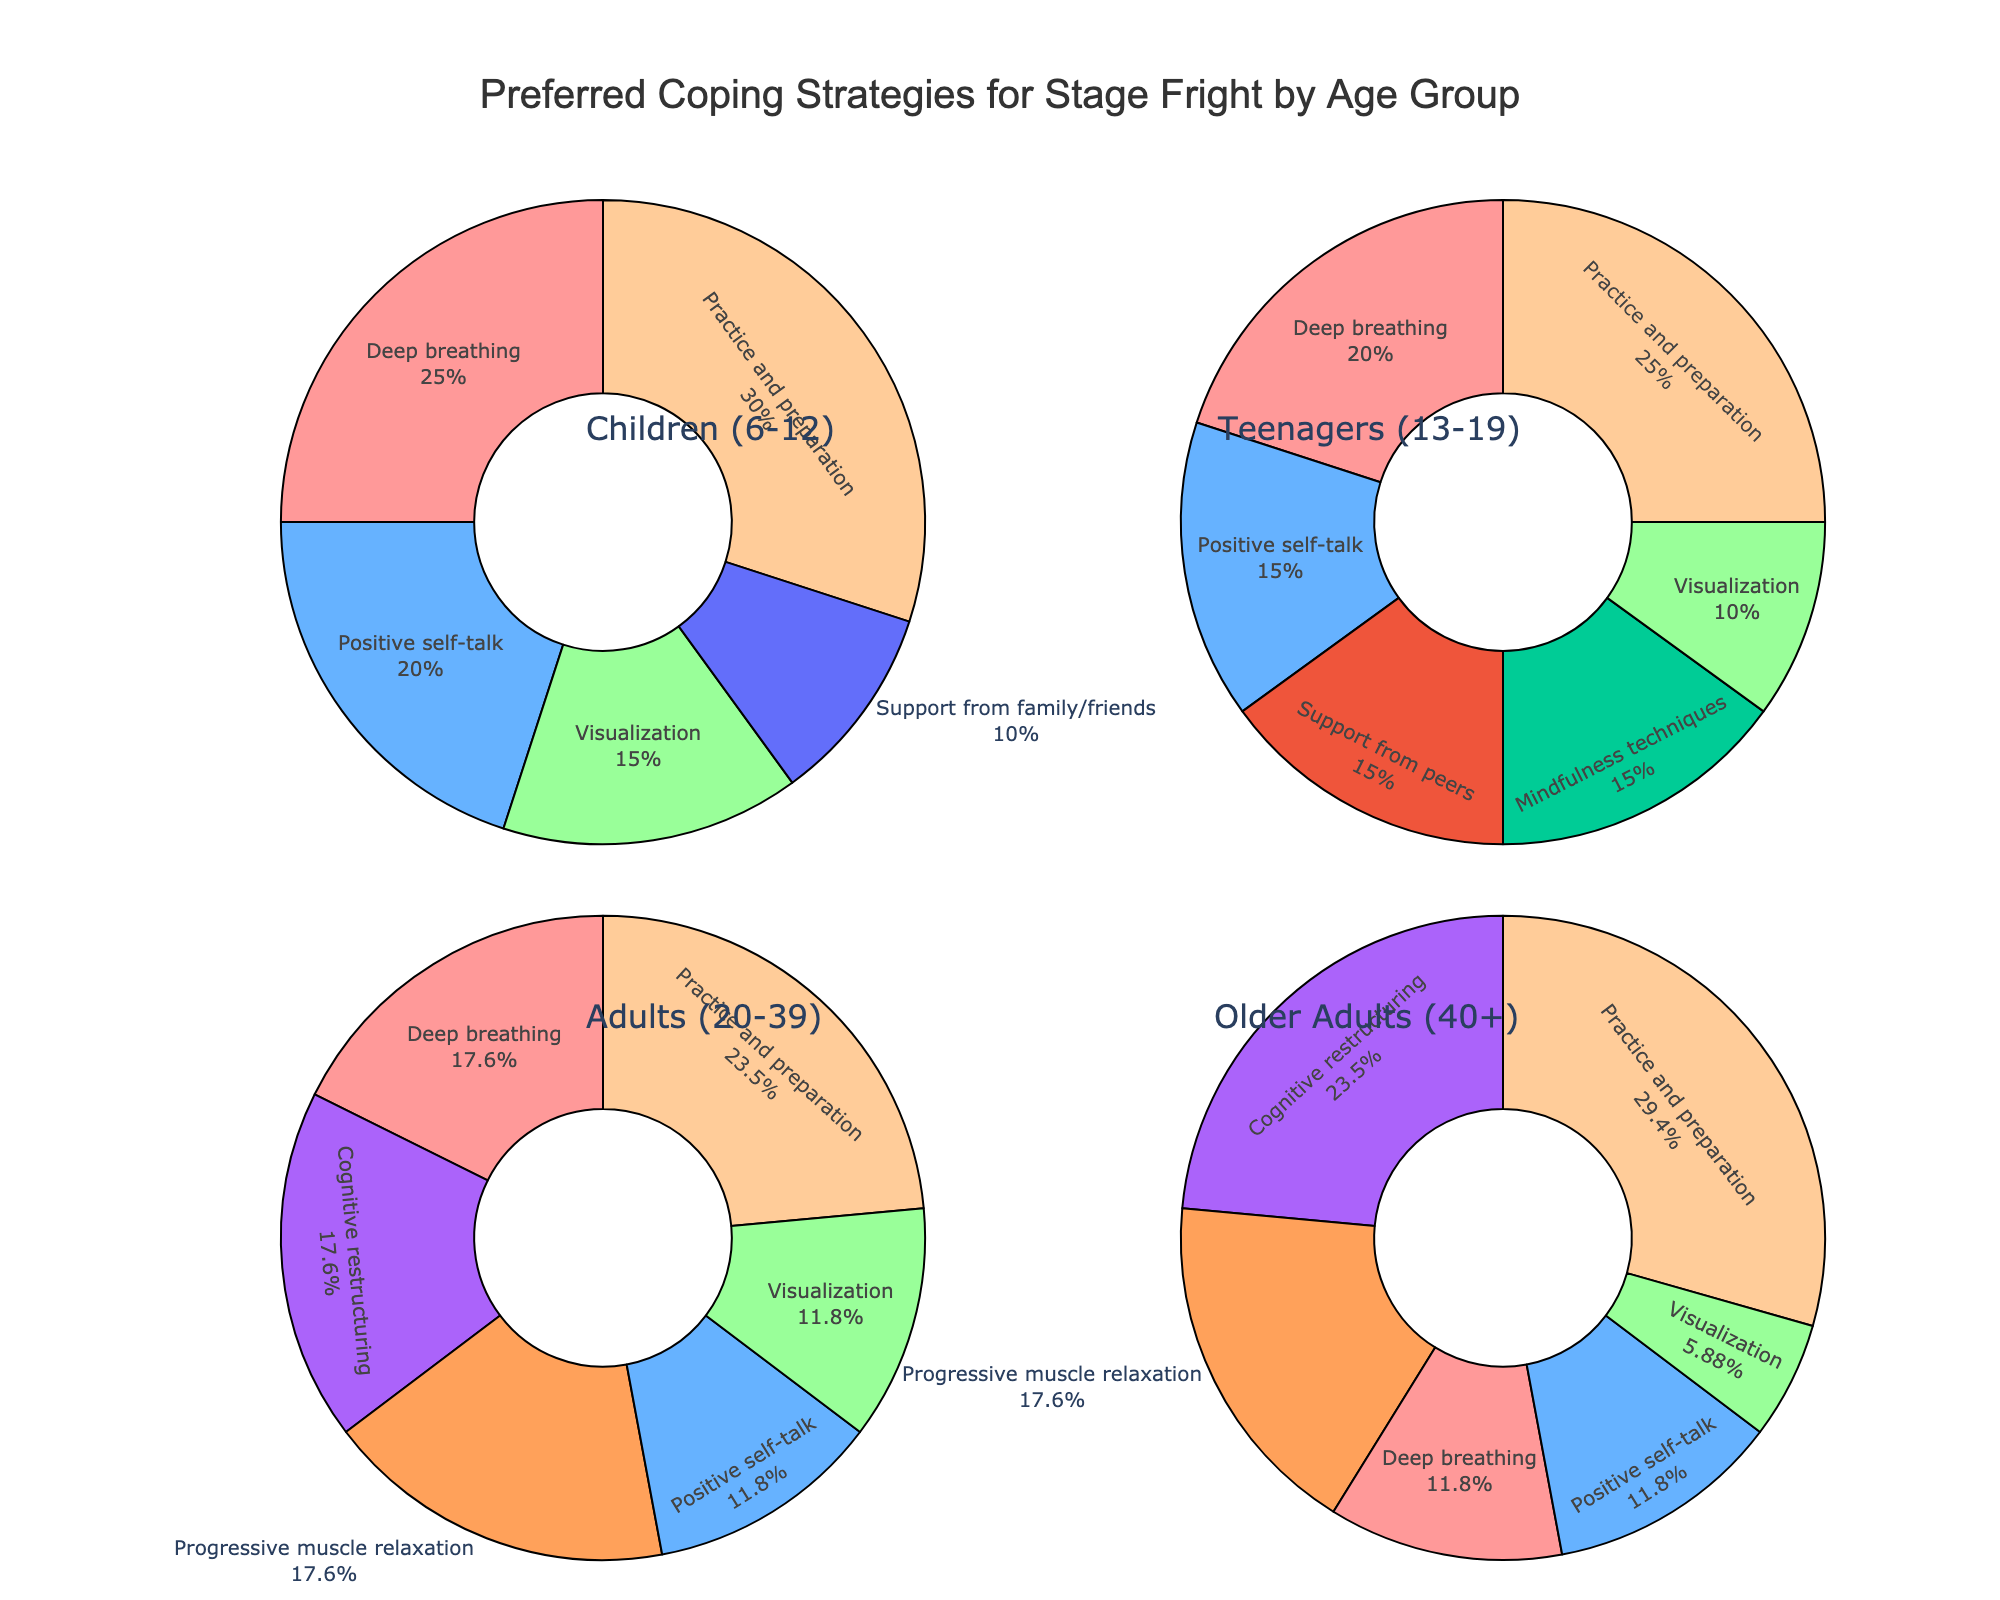What is the most preferred coping strategy among teenagers (13-19)? Looking at the pie chart for the Teenagers (13-19) group, the largest segment represents 'Practice and preparation' with 25%.
Answer: Practice and preparation How does the preference for 'Deep breathing' compare between Children (6-12) and Older Adults (40+)? In the pie charts, 'Deep breathing' is 25% for Children (6-12) and 10% for Older Adults (40+).
Answer: Children (6-12) prefer it more Which age group gives the least preference to 'Visualization'? The pie chart for Older Adults (40+) shows 'Visualization' at 5%, which is the lowest percentage among all age groups.
Answer: Older Adults (40+) Sum the percentages for 'Practice and preparation' across all age groups. Adding the percentages for 'Practice and preparation': Children (6-12) is 30%, Teenagers (13-19) is 25%, Adults (20-39) is 20%, Older Adults (40+) is 25%. The total is 30% + 25% + 20% + 25% = 100%.
Answer: 100% Compare the use of 'Positive self-talk' between Children (6-12) and Adults (20-39). In the charts, 'Positive self-talk' is 20% for Children (6-12) and 10% for Adults (20-39).
Answer: Children (6-12) prefer it more What percentage of Adults (20-39) prefer 'Cognitive restructuring'? The pie chart for Adults (20-39) shows 'Cognitive restructuring' at 15%.
Answer: 15% Which age group has the highest preference for 'Support from family/friends' or 'Support from peers'? The pie chart for Teenagers (13-19) shows 'Support from peers' at 15%, but 'Support from family/friends' for Children (6-12) is 10%. Thus, Teenagers prefer more.
Answer: Teenagers (13-19) How much more do Children (6-12) prefer 'Practice and preparation' than Adults (20-39)? For Children (6-12), 'Practice and preparation' is 30%, while for Adults (20-39), it is 20%. The difference is 30% - 20% = 10%.
Answer: 10% more Calculate the average percentage of 'Mindfulness techniques' and 'Progressive muscle relaxation' for Older Adults (40+). 'Mindfulness techniques' is not present for Older Adults (40+), but 'Progressive muscle relaxation' is 15%. So the average is (15% + 0%)/1 = 15%.
Answer: 15% 